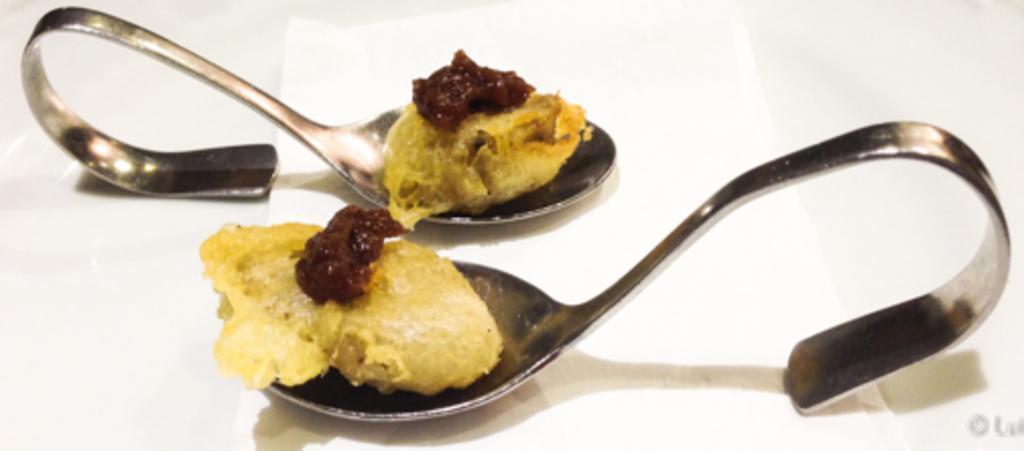Please provide a concise description of this image. In this image there is a table with two spoons on it and there is a food item on the spoons. 